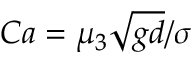Convert formula to latex. <formula><loc_0><loc_0><loc_500><loc_500>C a = \mu _ { 3 } \sqrt { g d } / \sigma</formula> 